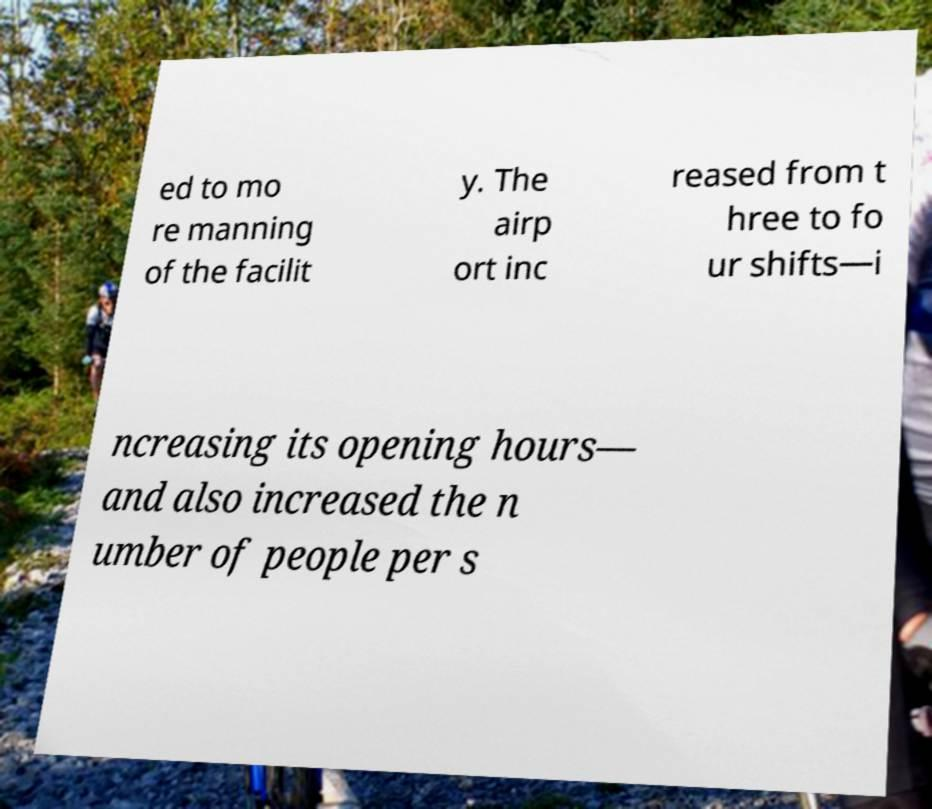Could you extract and type out the text from this image? ed to mo re manning of the facilit y. The airp ort inc reased from t hree to fo ur shifts—i ncreasing its opening hours— and also increased the n umber of people per s 